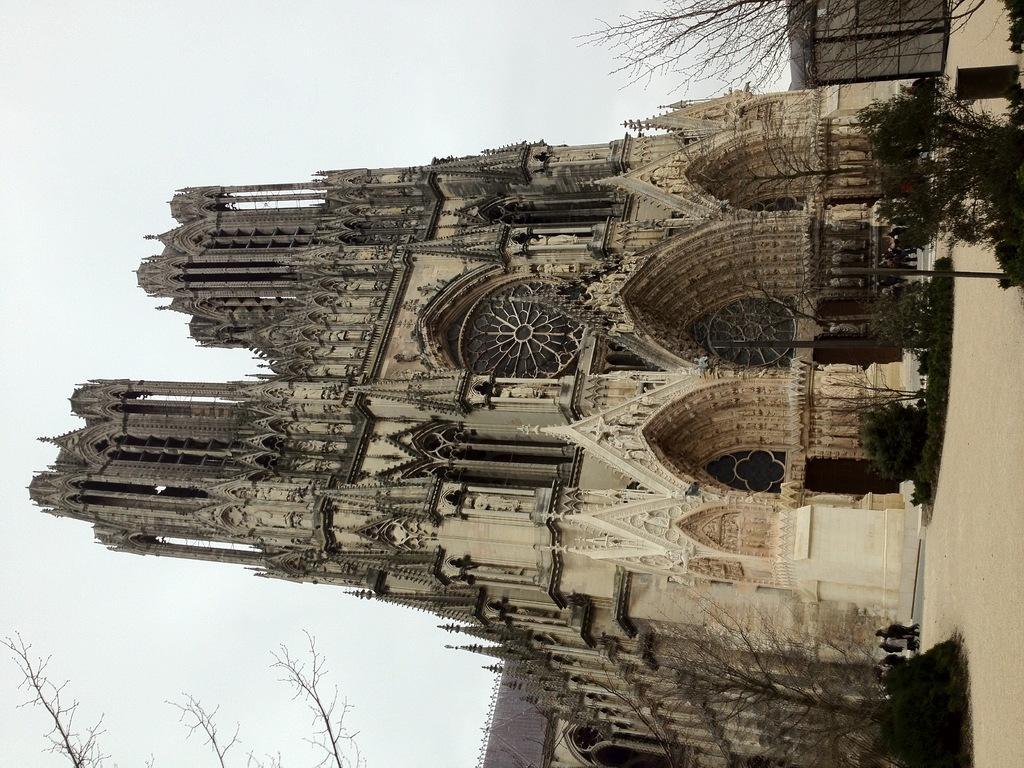Describe this image in one or two sentences. There are trees near a pole on the ground. In front of them, there is dry land. In the background, there are two persons walking on the road near plants, a tree and building which is having towers and designs. And this building is near trees and plants and there is sky. 